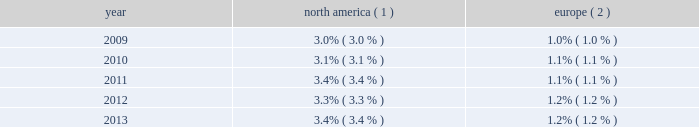Pullmantur during 2013 , we operated four ships with an aggre- gate capacity of approximately 7650 berths under our pullmantur brand , offering cruise itineraries that ranged from four to 12 nights throughout south america , the caribbean and europe .
One of these ships , zenith , was redeployed from pullmantur to cdf croisi e8res de france in january 2014 .
Pullmantur serves the contemporary segment of the spanish , portuguese and latin american cruise markets .
Pullmantur 2019s strategy is to attract cruise guests from these target markets by providing a variety of cruising options and onboard activities directed at couples and families traveling with children .
Over the last few years , pullmantur has systematically increased its focus on latin america .
In recognition of this , pullmantur recently opened a regional head office in panama to place the operating management closer to its largest and fastest growing market .
In order to facilitate pullmantur 2019s ability to focus on its core cruise business , in december 2013 , pullmantur reached an agreement to sell the majority of its inter- est in its land-based tour operations , travel agency and pullmantur air , the closing of which is subject to customary closing conditions .
In connection with the agreement , we will retain a 19% ( 19 % ) interest in the non-core businesses .
We will retain ownership of the pullmantur aircraft which will be dry leased to pullmantur air .
Cdf croisi e8res de france in january 2014 , we redeployed zenith from pullmantur to cdf croisi e8res de france .
As a result , as of january 2014 , we operate two ships with an aggregate capac- ity of approximately 2750 berths under our cdf croisi e8res de france brand .
During the summer of 2014 , cdf croisi e8res de france will operate both ships in europe and , for the first time , the brand will operate in the caribbean during the winter of 2014 .
In addition , cdf croisi e8res de france offers seasonal itineraries to the mediterranean .
Cdf croisi e8res de france is designed to serve the contemporary seg- ment of the french cruise market by providing a brand tailored for french cruise guests .
Tui cruises tui cruises is designed to serve the contemporary and premium segments of the german cruise market by offering a product tailored for german guests .
All onboard activities , services , shore excursions and menu offerings are designed to suit the preferences of this target market .
Tui cruises operates two ships , mein schiff 1 and mein schiff 2 , with an aggregate capacity of approximately 3800 berths .
In addition , tui cruises has two ships on order , each with a capacity of 2500 berths , scheduled for delivery in the second quarter of 2014 and second quarter of 2015 .
Tui cruises is a joint venture owned 50% ( 50 % ) by us and 50% ( 50 % ) by tui ag , a german tourism and shipping company that also owns 51% ( 51 % ) of tui travel , a british tourism company .
Industry cruising is considered a well-established vacation sector in the north american market , a growing sec- tor over the long-term in the european market and a developing but promising sector in several other emerging markets .
Industry data indicates that market penetration rates are still low and that a significant portion of cruise guests carried are first-time cruisers .
We believe this presents an opportunity for long-term growth and a potential for increased profitability .
The table details market penetration rates for north america and europe computed based on the number of annual cruise guests as a percentage of the total population : america ( 1 ) europe ( 2 ) .
( 1 ) source : international monetary fund and cruise line international association based on cruise guests carried for at least two con- secutive nights for years 2009 through 2012 .
Year 2013 amounts represent our estimates .
Includes the united states of america and canada .
( 2 ) source : international monetary fund and clia europe , formerly european cruise council , for years 2009 through 2012 .
Year 2013 amounts represent our estimates .
We estimate that the global cruise fleet was served by approximately 436000 berths on approximately 269 ships at the end of 2013 .
There are approximately 26 ships with an estimated 71000 berths that are expected to be placed in service in the global cruise market between 2014 and 2018 , although it is also possible that ships could be ordered or taken out of service during these periods .
We estimate that the global cruise industry carried 21.3 million cruise guests in 2013 compared to 20.9 million cruise guests carried in 2012 and 20.2 million cruise guests carried in 2011 .
Part i .
What is the average berths capacity on mein schiff 1 and mein schiff 2? 
Computations: (3800 / 2)
Answer: 1900.0. 